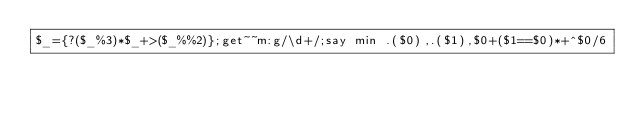Convert code to text. <code><loc_0><loc_0><loc_500><loc_500><_Perl_>$_={?($_%3)*$_+>($_%%2)};get~~m:g/\d+/;say min .($0),.($1),$0+($1==$0)*+^$0/6</code> 